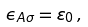<formula> <loc_0><loc_0><loc_500><loc_500>\epsilon _ { A \sigma } = \varepsilon _ { 0 } \, ,</formula> 